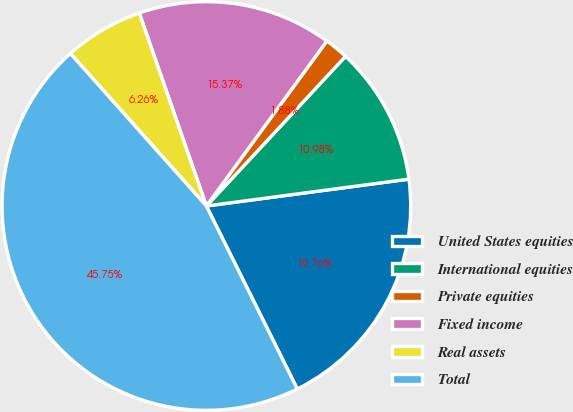<chart> <loc_0><loc_0><loc_500><loc_500><pie_chart><fcel>United States equities<fcel>International equities<fcel>Private equities<fcel>Fixed income<fcel>Real assets<fcel>Total<nl><fcel>19.76%<fcel>10.98%<fcel>1.88%<fcel>15.37%<fcel>6.26%<fcel>45.75%<nl></chart> 